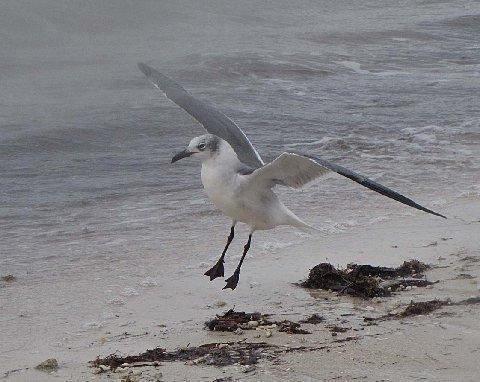How many birds are in the picture?
Give a very brief answer. 1. 